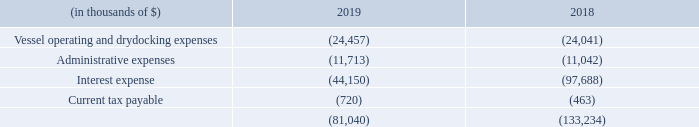19. ACCRUED EXPENSES
Vessel operating and drydocking expense related accruals are composed of vessel operating expenses such as crew wages, vessel supplies, routine repairs, maintenance, drydocking, lubricating oils and insurances.
Administrative expenses related accruals are comprised of general overhead including personnel costs, legal and professional fees, costs associated with project development, property costs and other general expenses.
The movement in interest expense is due to repayments of VIE entities' accrued interest expenses during the year.
What are the segments of accrued expenses? Vessel operating and drydocking expenses, administrative expenses, interest expense, current tax payable. What does administrative expenses represent? Comprised of general overhead including personnel costs, legal and professional fees, costs associated with project development, property costs and other general expenses. What accounted for the movement in interest expense? Due to repayments of vie entities' accrued interest expenses during the year. Which year has a higher interest expense? (97,688) > (44,150)
Answer: 2018. What was the change in administrative expense between 2018 and 2019?
Answer scale should be: thousand. (11,713) - (11,042) 
Answer: -671. What was the percentage change in current tax payable between 2018 and 2019?
Answer scale should be: percent. (720-463)/463
Answer: 55.51. 